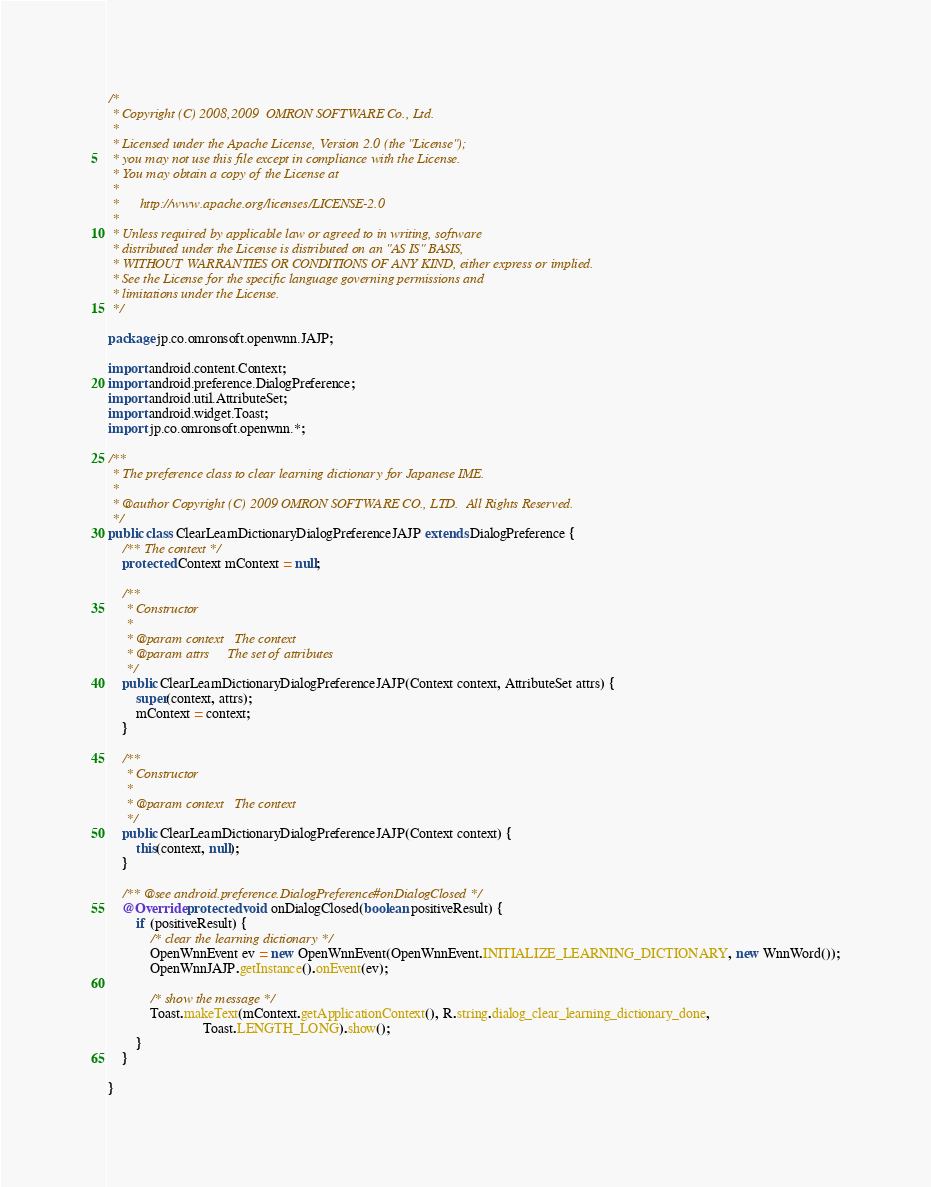<code> <loc_0><loc_0><loc_500><loc_500><_Java_>/*
 * Copyright (C) 2008,2009  OMRON SOFTWARE Co., Ltd.
 *
 * Licensed under the Apache License, Version 2.0 (the "License");
 * you may not use this file except in compliance with the License.
 * You may obtain a copy of the License at
 *
 *      http://www.apache.org/licenses/LICENSE-2.0
 *
 * Unless required by applicable law or agreed to in writing, software
 * distributed under the License is distributed on an "AS IS" BASIS,
 * WITHOUT WARRANTIES OR CONDITIONS OF ANY KIND, either express or implied.
 * See the License for the specific language governing permissions and
 * limitations under the License.
 */

package jp.co.omronsoft.openwnn.JAJP;

import android.content.Context;
import android.preference.DialogPreference;
import android.util.AttributeSet;
import android.widget.Toast;
import jp.co.omronsoft.openwnn.*;

/**
 * The preference class to clear learning dictionary for Japanese IME.
 *
 * @author Copyright (C) 2009 OMRON SOFTWARE CO., LTD.  All Rights Reserved.
 */
public class ClearLearnDictionaryDialogPreferenceJAJP extends DialogPreference {
    /** The context */
    protected Context mContext = null;

    /**
     * Constructor
     *
     * @param context   The context
     * @param attrs     The set of attributes
     */
    public ClearLearnDictionaryDialogPreferenceJAJP(Context context, AttributeSet attrs) {
        super(context, attrs);
        mContext = context;
    }
    
    /**
     * Constructor
     *
     * @param context   The context
     */
    public ClearLearnDictionaryDialogPreferenceJAJP(Context context) {
        this(context, null);
    }

    /** @see android.preference.DialogPreference#onDialogClosed */
    @Override protected void onDialogClosed(boolean positiveResult) {
        if (positiveResult) {
            /* clear the learning dictionary */
            OpenWnnEvent ev = new OpenWnnEvent(OpenWnnEvent.INITIALIZE_LEARNING_DICTIONARY, new WnnWord());
            OpenWnnJAJP.getInstance().onEvent(ev);

            /* show the message */
            Toast.makeText(mContext.getApplicationContext(), R.string.dialog_clear_learning_dictionary_done,
                           Toast.LENGTH_LONG).show();
        }
    }

}
</code> 